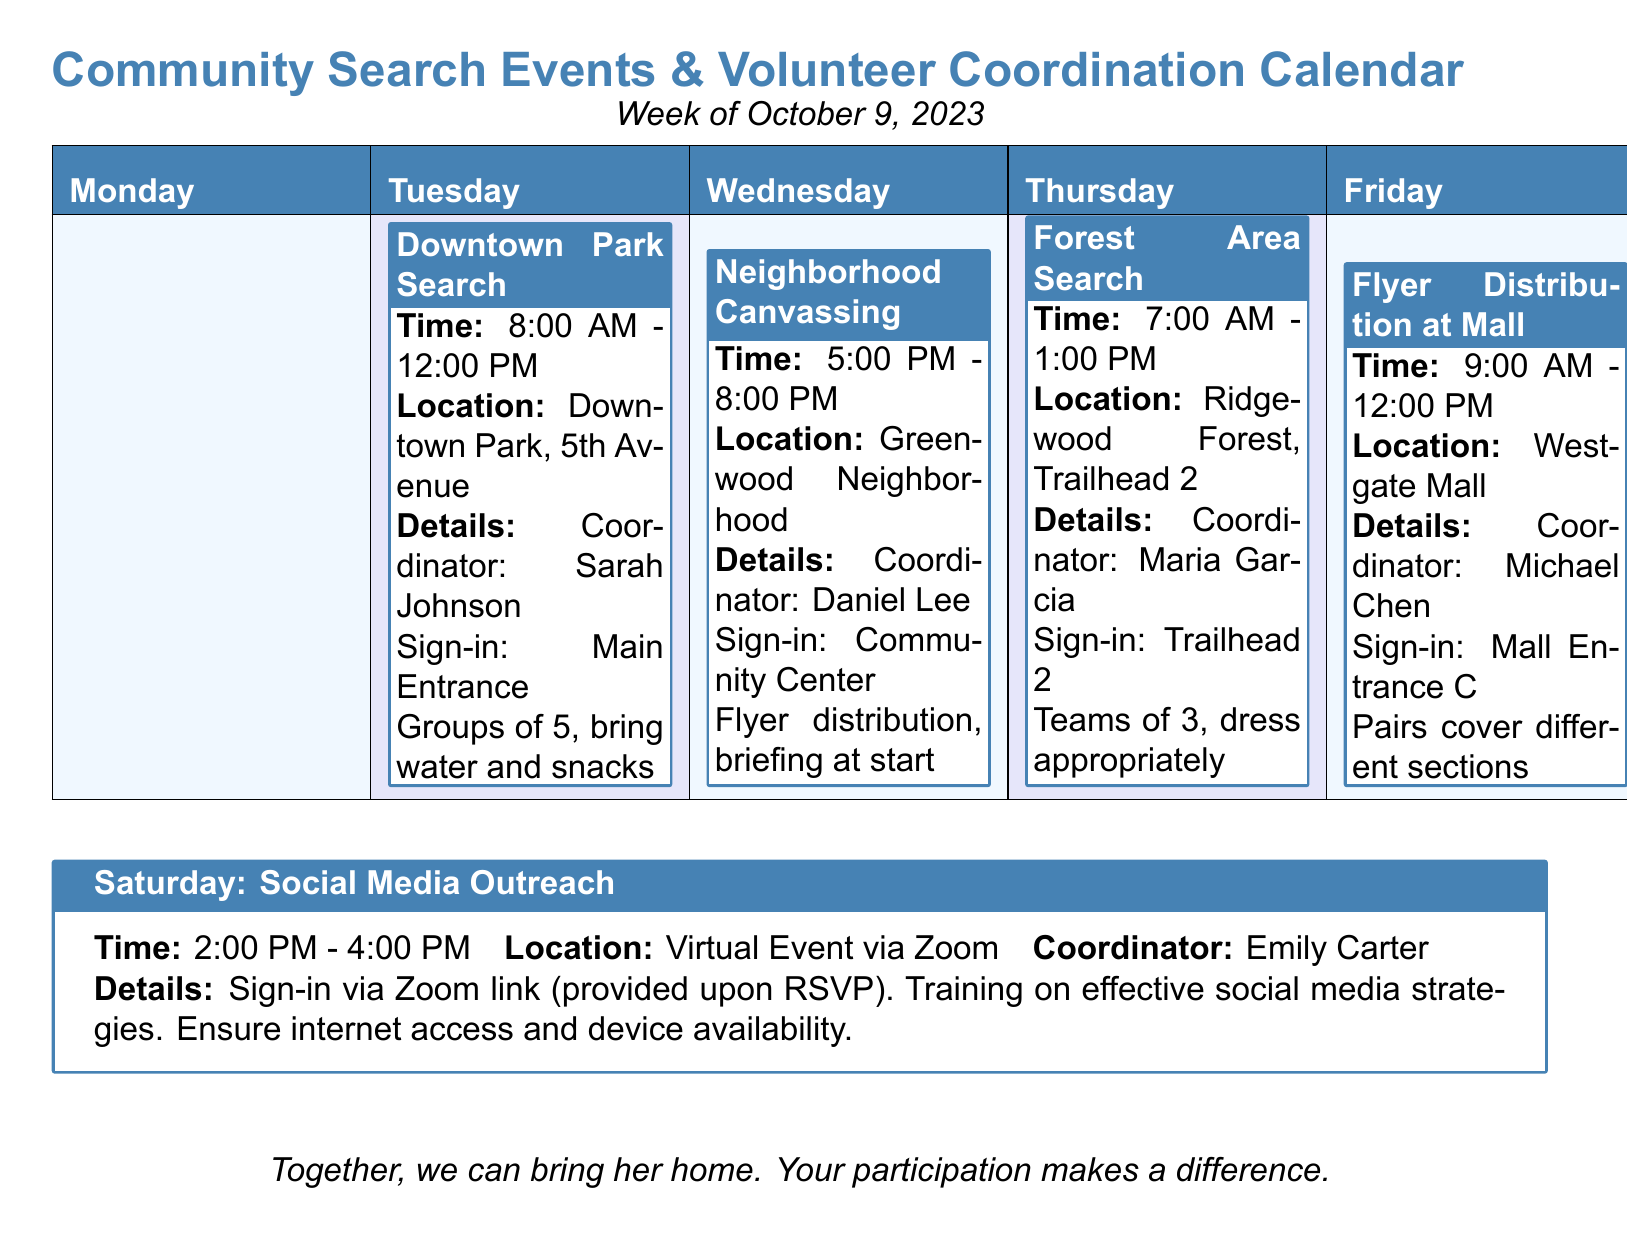what is the location of the Downtown Park Search? The location for the Downtown Park Search is stated in the event details.
Answer: Downtown Park, 5th Avenue who is the coordinator for the Neighborhood Canvassing event? The coordinator's name is listed with the details of the event.
Answer: Daniel Lee what type of event is scheduled for Saturday? The event type is indicated in the title of the scheduled activity for Saturday.
Answer: Social Media Outreach how long is the Forest Area Search scheduled for? The duration is specified by the start and end times listed in the event details.
Answer: 6 hours how many people are required for the Forest Area Search teams? The number of team members is mentioned in the event details for the Forest Area Search.
Answer: 3 what is the sign-in location for the Flyer Distribution at Mall? The sign-in location is mentioned in the details of the Flyer Distribution event.
Answer: Mall Entrance C how many total events are scheduled for the week? The total number of events can be counted from the table and additional information provided.
Answer: 5 what day is the Neighborhood Canvassing event held? The day of the event is indicated at the top of the respective column in the table.
Answer: Tuesday 